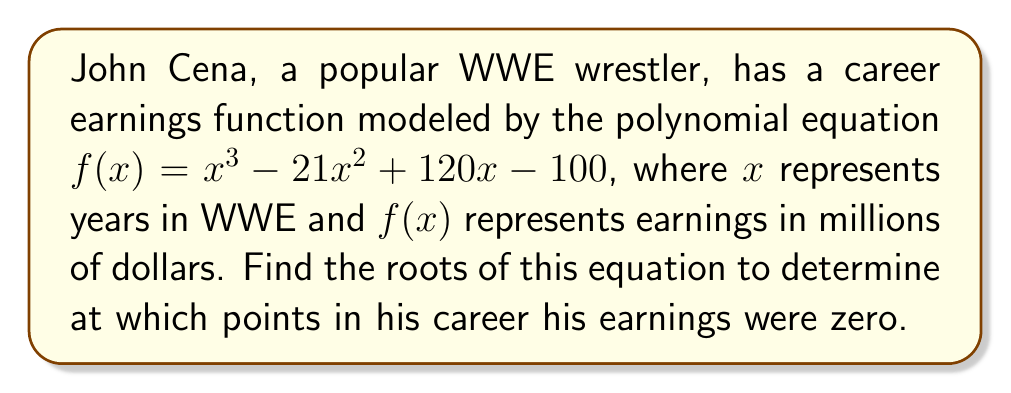Show me your answer to this math problem. To find the roots of the polynomial equation, we need to factor it:

1) First, let's check if there are any rational roots using the rational root theorem. The possible rational roots are the factors of the constant term: ±1, ±2, ±4, ±5, ±10, ±20, ±25, ±50, ±100.

2) Testing these values, we find that $f(1) = 0$. So $(x-1)$ is a factor.

3) Divide the polynomial by $(x-1)$:

   $\frac{x^3 - 21x^2 + 120x - 100}{x-1} = x^2 - 20x + 100$

4) Now we have: $f(x) = (x-1)(x^2 - 20x + 100)$

5) The quadratic factor $x^2 - 20x + 100$ can be factored further:

   $x^2 - 20x + 100 = (x-10)^2$

6) Therefore, the fully factored polynomial is:

   $f(x) = (x-1)(x-10)^2$

7) The roots are the values that make each factor equal to zero:
   $x-1 = 0$ or $x-10 = 0$

   So, $x = 1$ or $x = 10$
Answer: $x = 1$ and $x = 10$ (with $x = 10$ being a double root) 